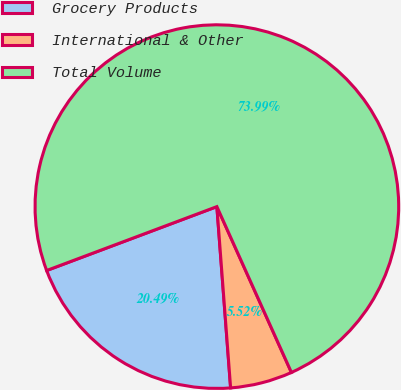Convert chart to OTSL. <chart><loc_0><loc_0><loc_500><loc_500><pie_chart><fcel>Grocery Products<fcel>International & Other<fcel>Total Volume<nl><fcel>20.49%<fcel>5.52%<fcel>73.99%<nl></chart> 